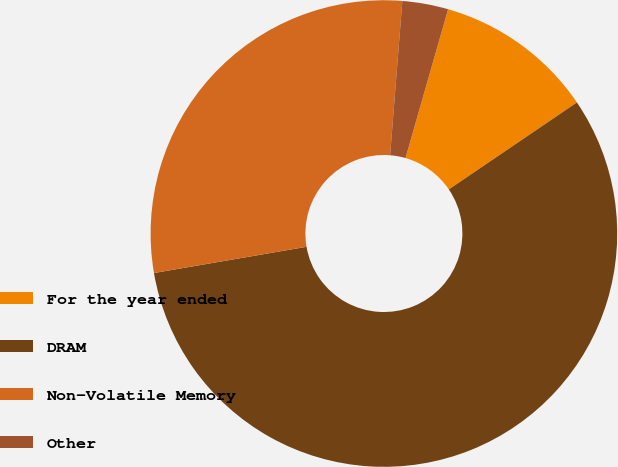<chart> <loc_0><loc_0><loc_500><loc_500><pie_chart><fcel>For the year ended<fcel>DRAM<fcel>Non-Volatile Memory<fcel>Other<nl><fcel>11.07%<fcel>56.79%<fcel>28.97%<fcel>3.18%<nl></chart> 